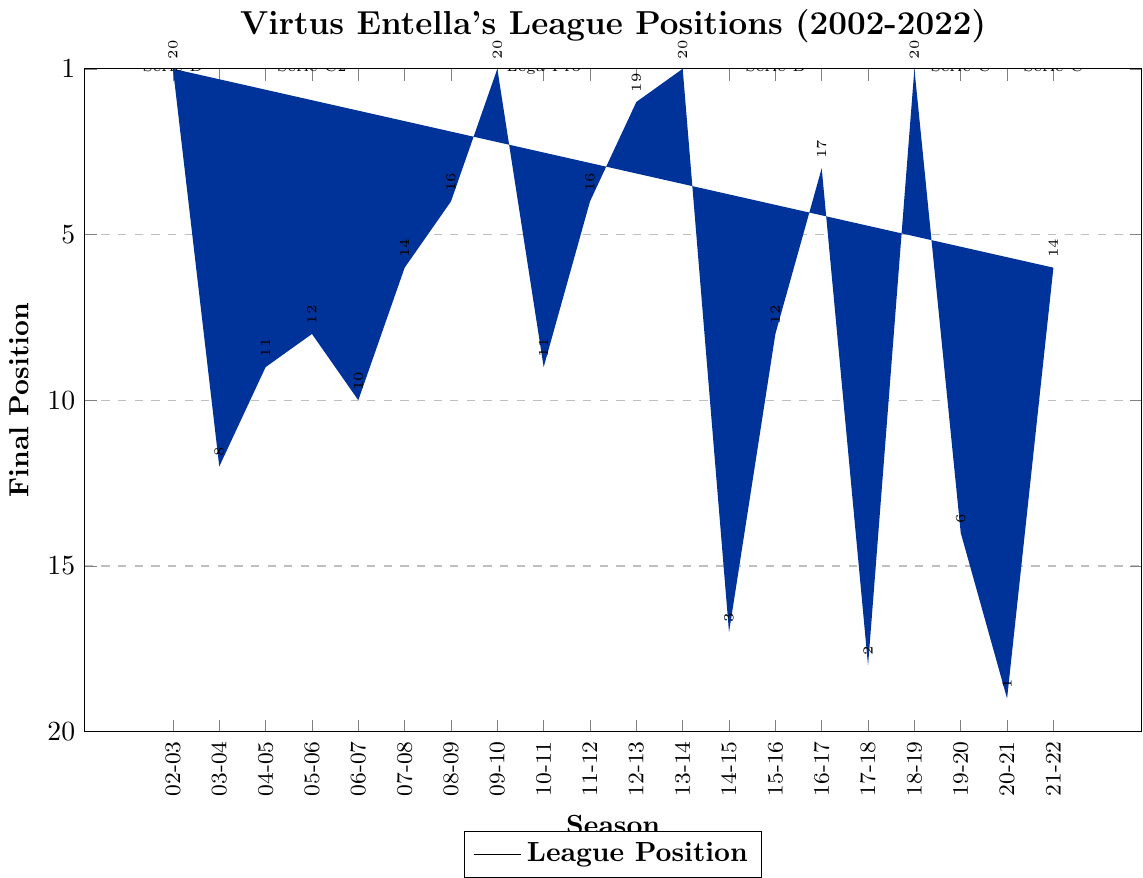What is the final position of Virtus Entella in the 2002-03 season? The 2002-03 season is the first bar in the chart. The bar reaches the top position, which corresponds to 1 on the Y-axis.
Answer: 1 In which season did Virtus Entella finish 1st in Serie D? Look at the bars labeled "Serie D". The bar at "2002-03" season finishes at position 1.
Answer: 2002-03 How many times did Virtus Entella finish in the top 5 positions overall? Scan through each bar and count the number of times the bar reaches the 5th position or better (positions 1 to 5). These seasons are 2002-03, 2009-10, 2012-13, 2013-14, 2016-17, and 2018-19.
Answer: 6 Which season had the worst performance for Virtus Entella in Serie B? Check among the seasons labeled as "Serie B". The worst position is represented by the highest bar, which is 2020-21 when the bar reaches 20th place.
Answer: 2020-21 Compare Virtus Entella's final positions in the last two seasons shown in the chart. Which season had a better performance? Compare the bars for the last two seasons, 2020-21 and 2021-22. The bar for 2021-22 is lower on the chart (position 7) compared to 2020-21 (position 20).
Answer: 2021-22 How did Virtus Entella perform in the 2017-18 season compared to the 2016-17 season? Look at bars for 2016-17 and 2017-18. In 2016-17, they finished in position 4, while in 2017-18, they finished in position 19, indicating a worse performance in 2017-18.
Answer: 2016-17 was better What is the average final position of Virtus Entella in Serie B across all relevant seasons? Look at the bars for Serie B: 2014-15 (18), 2015-16 (9), 2016-17 (4), 2017-18 (19), 2019-20 (15), 2020-21 (20). Calculate the average: (18 + 9 + 4 + 19 + 15 + 20) / 6 = 14.17
Answer: 14.17 In which season did Virtus Entella achieve their best position in Lega Pro Prima Divisione? Look at the bars labeled "Lega Pro Prima Divisione". The best position is the lowest bar in 2013-14, which corresponds to 1st place.
Answer: 2013-14 How many times did Virtus Entella win their division in the provided seasons? Count the number of times the bar reaches position 1 across all seasons. These are 2002-03, 2009-10, 2013-14, and 2018-19.
Answer: 4 